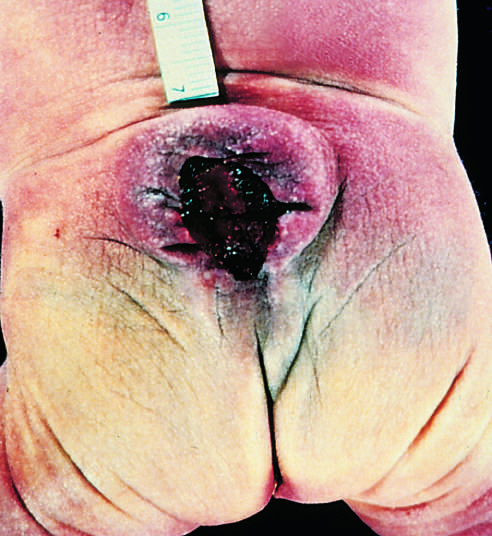what are included in the cystlike structure visible just above the buttocks?
Answer the question using a single word or phrase. Both meninges and spinal cord parenchyma 